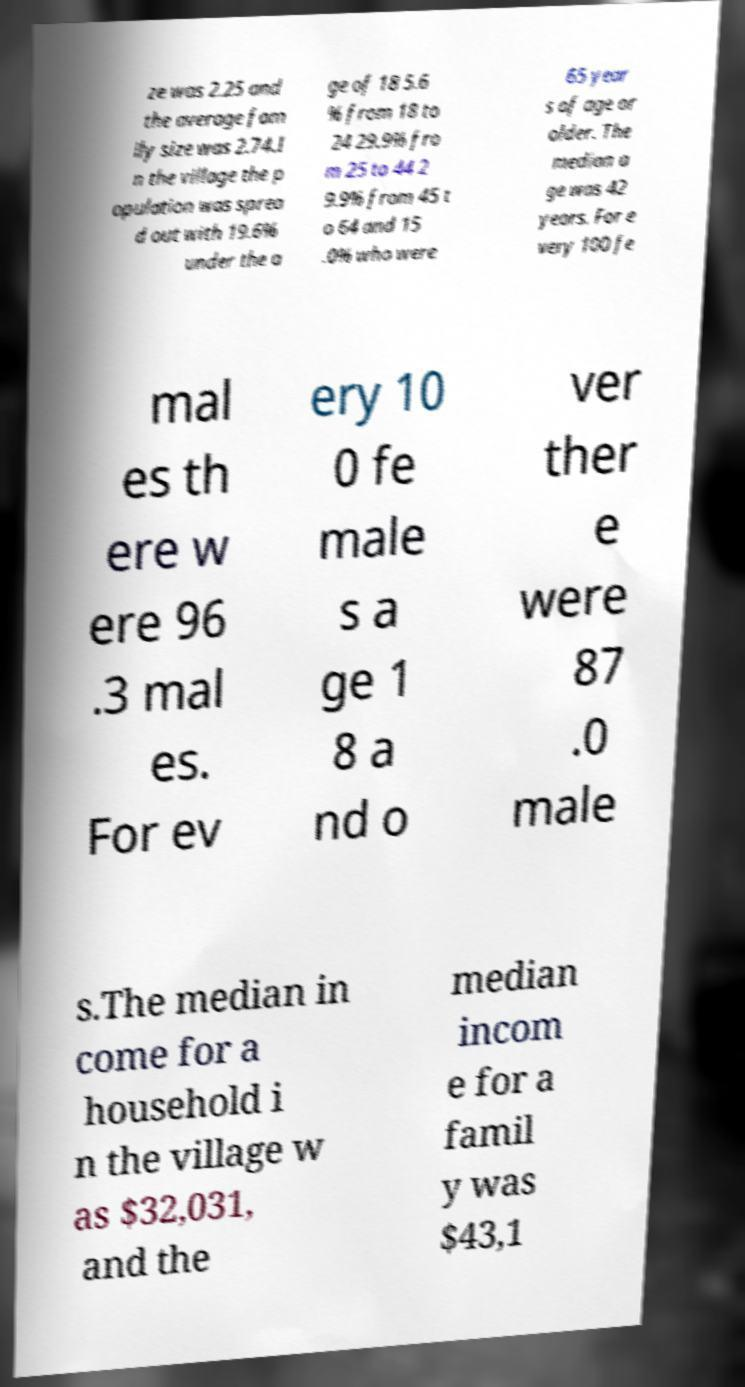Can you read and provide the text displayed in the image?This photo seems to have some interesting text. Can you extract and type it out for me? ze was 2.25 and the average fam ily size was 2.74.I n the village the p opulation was sprea d out with 19.6% under the a ge of 18 5.6 % from 18 to 24 29.9% fro m 25 to 44 2 9.9% from 45 t o 64 and 15 .0% who were 65 year s of age or older. The median a ge was 42 years. For e very 100 fe mal es th ere w ere 96 .3 mal es. For ev ery 10 0 fe male s a ge 1 8 a nd o ver ther e were 87 .0 male s.The median in come for a household i n the village w as $32,031, and the median incom e for a famil y was $43,1 